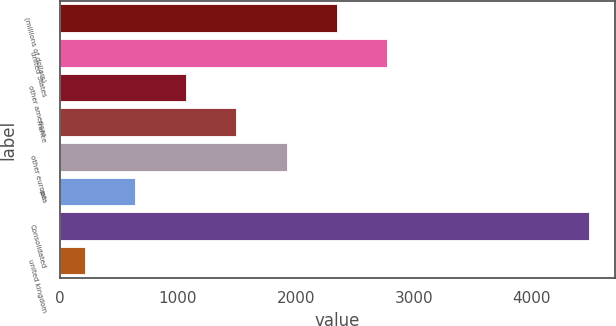Convert chart to OTSL. <chart><loc_0><loc_0><loc_500><loc_500><bar_chart><fcel>(millions of dollars)<fcel>united States<fcel>other americas<fcel>France<fcel>other europe<fcel>asia<fcel>Consolidated<fcel>united kingdom<nl><fcel>2349.1<fcel>2776.04<fcel>1068.28<fcel>1495.22<fcel>1922.16<fcel>641.34<fcel>4483.8<fcel>214.4<nl></chart> 